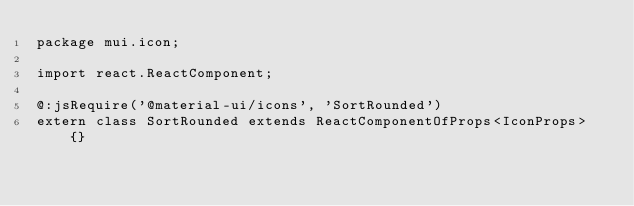<code> <loc_0><loc_0><loc_500><loc_500><_Haxe_>package mui.icon;

import react.ReactComponent;

@:jsRequire('@material-ui/icons', 'SortRounded')
extern class SortRounded extends ReactComponentOfProps<IconProps> {}
</code> 